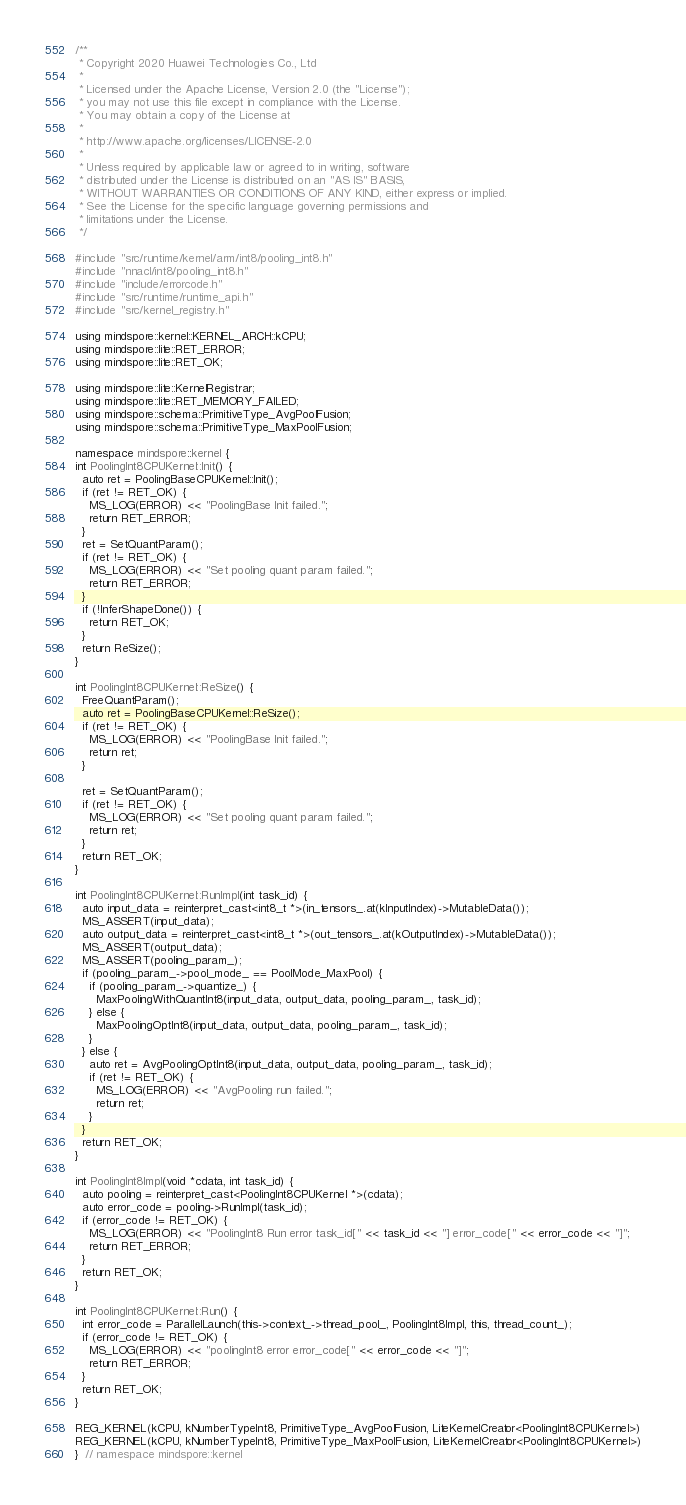Convert code to text. <code><loc_0><loc_0><loc_500><loc_500><_C++_>/**
 * Copyright 2020 Huawei Technologies Co., Ltd
 *
 * Licensed under the Apache License, Version 2.0 (the "License");
 * you may not use this file except in compliance with the License.
 * You may obtain a copy of the License at
 *
 * http://www.apache.org/licenses/LICENSE-2.0
 *
 * Unless required by applicable law or agreed to in writing, software
 * distributed under the License is distributed on an "AS IS" BASIS,
 * WITHOUT WARRANTIES OR CONDITIONS OF ANY KIND, either express or implied.
 * See the License for the specific language governing permissions and
 * limitations under the License.
 */

#include "src/runtime/kernel/arm/int8/pooling_int8.h"
#include "nnacl/int8/pooling_int8.h"
#include "include/errorcode.h"
#include "src/runtime/runtime_api.h"
#include "src/kernel_registry.h"

using mindspore::kernel::KERNEL_ARCH::kCPU;
using mindspore::lite::RET_ERROR;
using mindspore::lite::RET_OK;

using mindspore::lite::KernelRegistrar;
using mindspore::lite::RET_MEMORY_FAILED;
using mindspore::schema::PrimitiveType_AvgPoolFusion;
using mindspore::schema::PrimitiveType_MaxPoolFusion;

namespace mindspore::kernel {
int PoolingInt8CPUKernel::Init() {
  auto ret = PoolingBaseCPUKernel::Init();
  if (ret != RET_OK) {
    MS_LOG(ERROR) << "PoolingBase Init failed.";
    return RET_ERROR;
  }
  ret = SetQuantParam();
  if (ret != RET_OK) {
    MS_LOG(ERROR) << "Set pooling quant param failed.";
    return RET_ERROR;
  }
  if (!InferShapeDone()) {
    return RET_OK;
  }
  return ReSize();
}

int PoolingInt8CPUKernel::ReSize() {
  FreeQuantParam();
  auto ret = PoolingBaseCPUKernel::ReSize();
  if (ret != RET_OK) {
    MS_LOG(ERROR) << "PoolingBase Init failed.";
    return ret;
  }

  ret = SetQuantParam();
  if (ret != RET_OK) {
    MS_LOG(ERROR) << "Set pooling quant param failed.";
    return ret;
  }
  return RET_OK;
}

int PoolingInt8CPUKernel::RunImpl(int task_id) {
  auto input_data = reinterpret_cast<int8_t *>(in_tensors_.at(kInputIndex)->MutableData());
  MS_ASSERT(input_data);
  auto output_data = reinterpret_cast<int8_t *>(out_tensors_.at(kOutputIndex)->MutableData());
  MS_ASSERT(output_data);
  MS_ASSERT(pooling_param_);
  if (pooling_param_->pool_mode_ == PoolMode_MaxPool) {
    if (pooling_param_->quantize_) {
      MaxPoolingWithQuantInt8(input_data, output_data, pooling_param_, task_id);
    } else {
      MaxPoolingOptInt8(input_data, output_data, pooling_param_, task_id);
    }
  } else {
    auto ret = AvgPoolingOptInt8(input_data, output_data, pooling_param_, task_id);
    if (ret != RET_OK) {
      MS_LOG(ERROR) << "AvgPooling run failed.";
      return ret;
    }
  }
  return RET_OK;
}

int PoolingInt8Impl(void *cdata, int task_id) {
  auto pooling = reinterpret_cast<PoolingInt8CPUKernel *>(cdata);
  auto error_code = pooling->RunImpl(task_id);
  if (error_code != RET_OK) {
    MS_LOG(ERROR) << "PoolingInt8 Run error task_id[" << task_id << "] error_code[" << error_code << "]";
    return RET_ERROR;
  }
  return RET_OK;
}

int PoolingInt8CPUKernel::Run() {
  int error_code = ParallelLaunch(this->context_->thread_pool_, PoolingInt8Impl, this, thread_count_);
  if (error_code != RET_OK) {
    MS_LOG(ERROR) << "poolingInt8 error error_code[" << error_code << "]";
    return RET_ERROR;
  }
  return RET_OK;
}

REG_KERNEL(kCPU, kNumberTypeInt8, PrimitiveType_AvgPoolFusion, LiteKernelCreator<PoolingInt8CPUKernel>)
REG_KERNEL(kCPU, kNumberTypeInt8, PrimitiveType_MaxPoolFusion, LiteKernelCreator<PoolingInt8CPUKernel>)
}  // namespace mindspore::kernel
</code> 